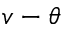Convert formula to latex. <formula><loc_0><loc_0><loc_500><loc_500>v - \theta</formula> 